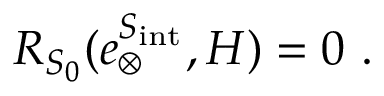<formula> <loc_0><loc_0><loc_500><loc_500>R _ { S _ { 0 } } ( e _ { \otimes } ^ { S _ { i n t } } , H ) = 0 \ .</formula> 